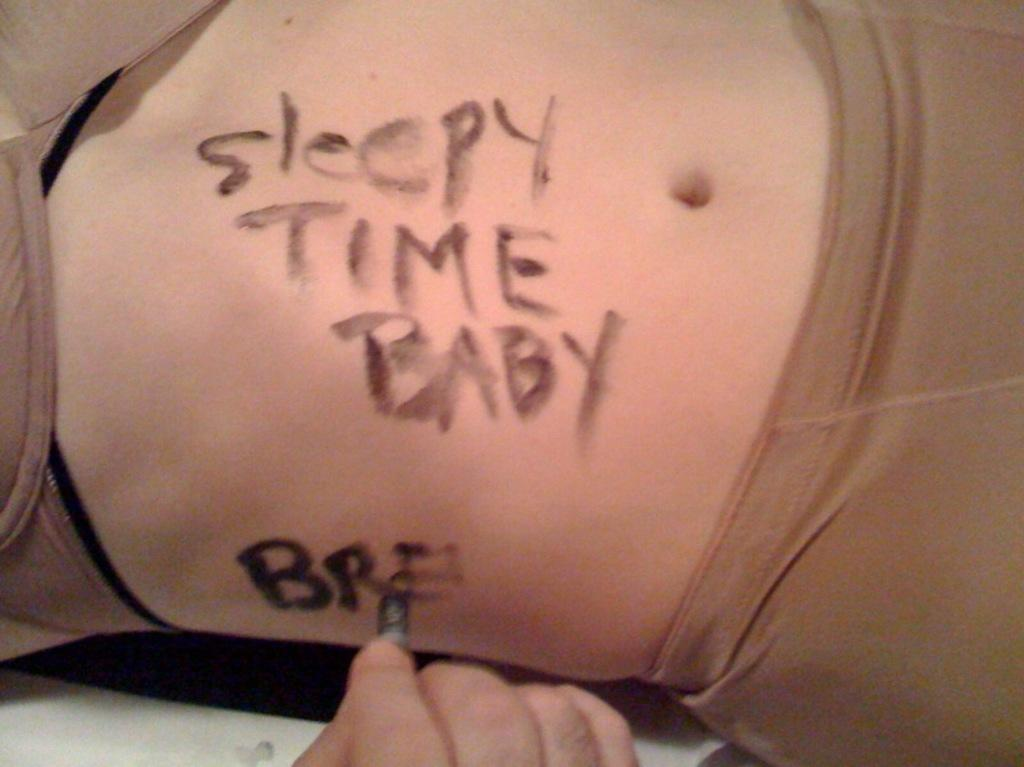What part of a woman's body is visible in the image? There is a woman's stomach in the image. What is on the woman's stomach? Something is written on the woman's stomach. What else can be seen in the image? There is a person's hand in the image. What is the person doing with their hand? The person is writing something on the woman's stomach. What color is the gun that the person is holding in the image? There is no gun present in the image; the person is using their hand to write on the woman's stomach. 